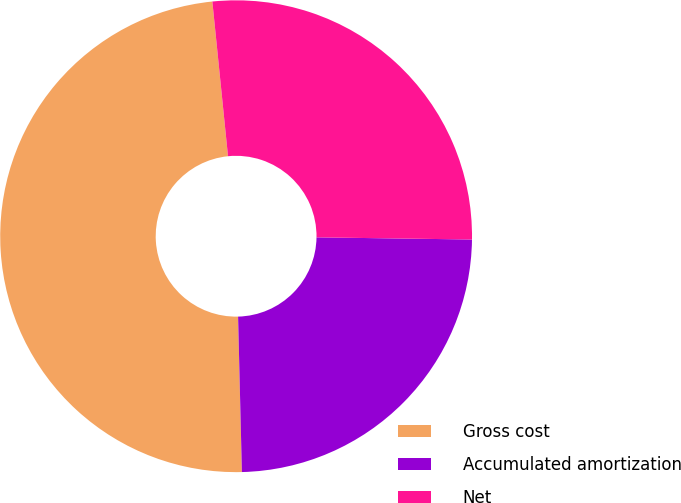<chart> <loc_0><loc_0><loc_500><loc_500><pie_chart><fcel>Gross cost<fcel>Accumulated amortization<fcel>Net<nl><fcel>48.79%<fcel>24.39%<fcel>26.83%<nl></chart> 